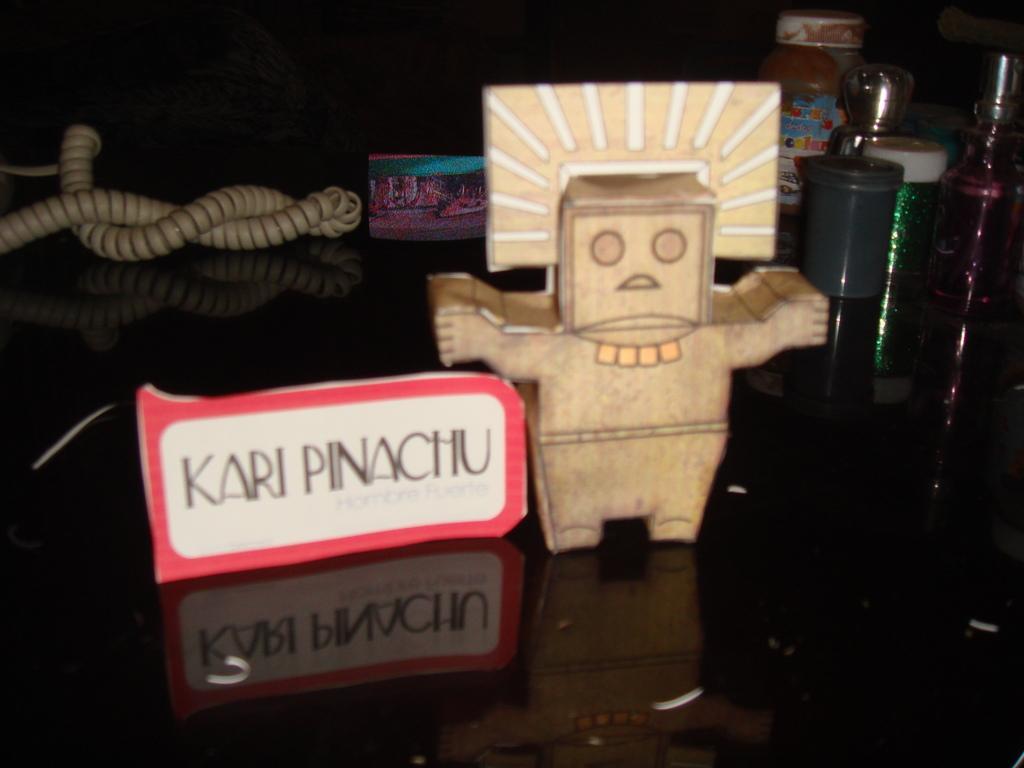Can you describe this image briefly? There is an object and there is kari pinachu written beside it and there are few other objects in the background. 